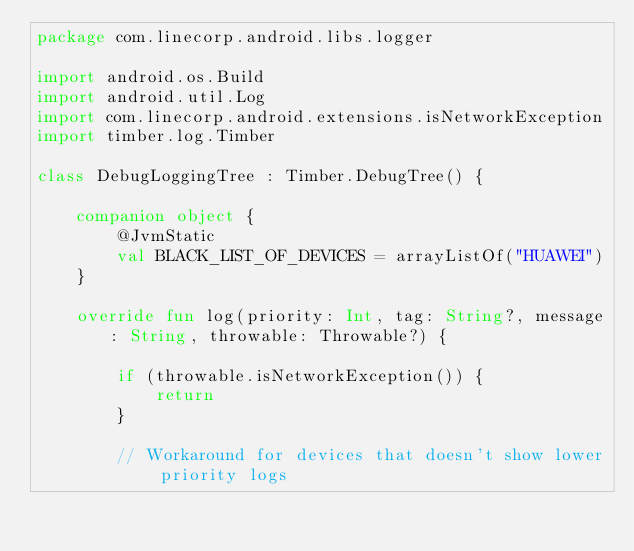<code> <loc_0><loc_0><loc_500><loc_500><_Kotlin_>package com.linecorp.android.libs.logger

import android.os.Build
import android.util.Log
import com.linecorp.android.extensions.isNetworkException
import timber.log.Timber

class DebugLoggingTree : Timber.DebugTree() {

    companion object {
        @JvmStatic
        val BLACK_LIST_OF_DEVICES = arrayListOf("HUAWEI")
    }

    override fun log(priority: Int, tag: String?, message: String, throwable: Throwable?) {

        if (throwable.isNetworkException()) {
            return
        }

        // Workaround for devices that doesn't show lower priority logs</code> 